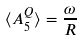Convert formula to latex. <formula><loc_0><loc_0><loc_500><loc_500>\langle A _ { 5 } ^ { Q } \rangle = \frac { \omega } { R }</formula> 